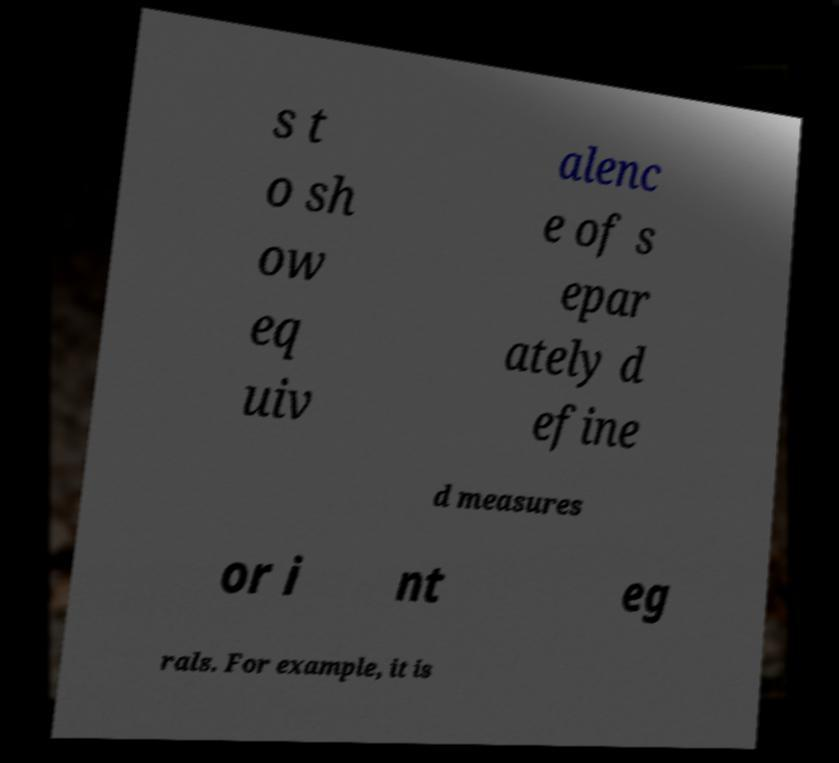What messages or text are displayed in this image? I need them in a readable, typed format. s t o sh ow eq uiv alenc e of s epar ately d efine d measures or i nt eg rals. For example, it is 